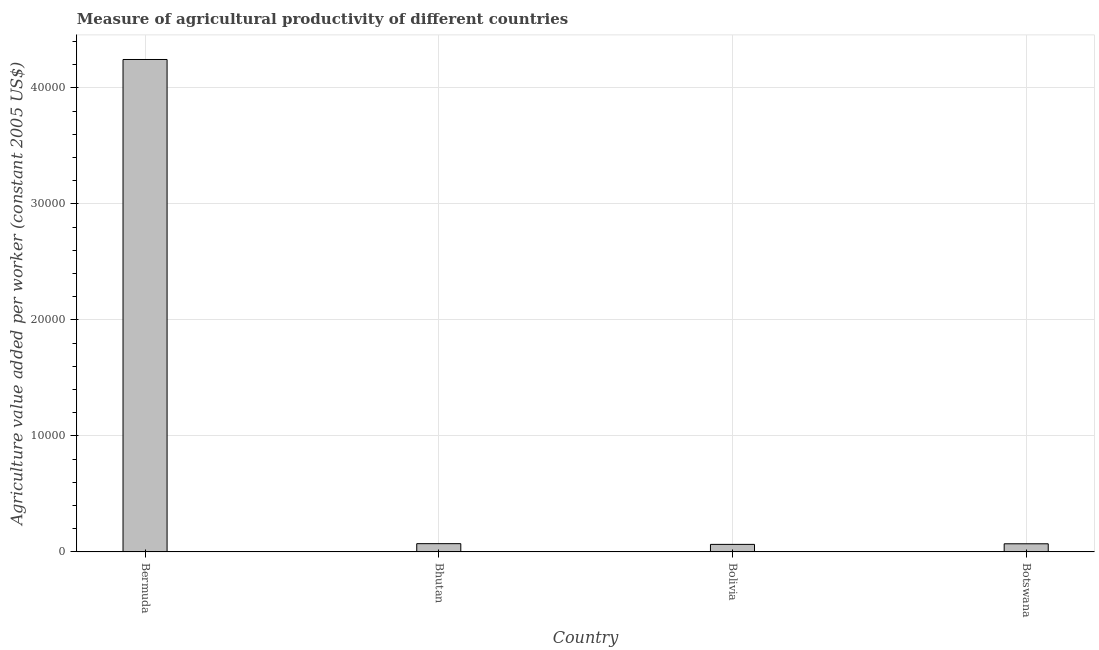Does the graph contain any zero values?
Your answer should be very brief. No. Does the graph contain grids?
Keep it short and to the point. Yes. What is the title of the graph?
Offer a terse response. Measure of agricultural productivity of different countries. What is the label or title of the Y-axis?
Offer a very short reply. Agriculture value added per worker (constant 2005 US$). What is the agriculture value added per worker in Bermuda?
Keep it short and to the point. 4.24e+04. Across all countries, what is the maximum agriculture value added per worker?
Provide a succinct answer. 4.24e+04. Across all countries, what is the minimum agriculture value added per worker?
Offer a very short reply. 649.37. In which country was the agriculture value added per worker maximum?
Give a very brief answer. Bermuda. In which country was the agriculture value added per worker minimum?
Provide a succinct answer. Bolivia. What is the sum of the agriculture value added per worker?
Your answer should be very brief. 4.45e+04. What is the difference between the agriculture value added per worker in Bhutan and Bolivia?
Provide a short and direct response. 60.99. What is the average agriculture value added per worker per country?
Offer a terse response. 1.11e+04. What is the median agriculture value added per worker?
Ensure brevity in your answer.  705.15. What is the ratio of the agriculture value added per worker in Bhutan to that in Bolivia?
Give a very brief answer. 1.09. Is the agriculture value added per worker in Bolivia less than that in Botswana?
Your answer should be compact. Yes. Is the difference between the agriculture value added per worker in Bermuda and Botswana greater than the difference between any two countries?
Keep it short and to the point. No. What is the difference between the highest and the second highest agriculture value added per worker?
Your answer should be very brief. 4.17e+04. Is the sum of the agriculture value added per worker in Bermuda and Bhutan greater than the maximum agriculture value added per worker across all countries?
Offer a terse response. Yes. What is the difference between the highest and the lowest agriculture value added per worker?
Offer a very short reply. 4.18e+04. In how many countries, is the agriculture value added per worker greater than the average agriculture value added per worker taken over all countries?
Your answer should be very brief. 1. How many bars are there?
Your answer should be compact. 4. Are all the bars in the graph horizontal?
Give a very brief answer. No. How many countries are there in the graph?
Your response must be concise. 4. What is the Agriculture value added per worker (constant 2005 US$) in Bermuda?
Your answer should be very brief. 4.24e+04. What is the Agriculture value added per worker (constant 2005 US$) of Bhutan?
Offer a very short reply. 710.36. What is the Agriculture value added per worker (constant 2005 US$) in Bolivia?
Your answer should be compact. 649.37. What is the Agriculture value added per worker (constant 2005 US$) in Botswana?
Offer a terse response. 699.93. What is the difference between the Agriculture value added per worker (constant 2005 US$) in Bermuda and Bhutan?
Give a very brief answer. 4.17e+04. What is the difference between the Agriculture value added per worker (constant 2005 US$) in Bermuda and Bolivia?
Provide a short and direct response. 4.18e+04. What is the difference between the Agriculture value added per worker (constant 2005 US$) in Bermuda and Botswana?
Ensure brevity in your answer.  4.17e+04. What is the difference between the Agriculture value added per worker (constant 2005 US$) in Bhutan and Bolivia?
Keep it short and to the point. 60.99. What is the difference between the Agriculture value added per worker (constant 2005 US$) in Bhutan and Botswana?
Provide a succinct answer. 10.43. What is the difference between the Agriculture value added per worker (constant 2005 US$) in Bolivia and Botswana?
Offer a very short reply. -50.56. What is the ratio of the Agriculture value added per worker (constant 2005 US$) in Bermuda to that in Bhutan?
Your answer should be compact. 59.75. What is the ratio of the Agriculture value added per worker (constant 2005 US$) in Bermuda to that in Bolivia?
Make the answer very short. 65.36. What is the ratio of the Agriculture value added per worker (constant 2005 US$) in Bermuda to that in Botswana?
Give a very brief answer. 60.64. What is the ratio of the Agriculture value added per worker (constant 2005 US$) in Bhutan to that in Bolivia?
Ensure brevity in your answer.  1.09. What is the ratio of the Agriculture value added per worker (constant 2005 US$) in Bhutan to that in Botswana?
Provide a short and direct response. 1.01. What is the ratio of the Agriculture value added per worker (constant 2005 US$) in Bolivia to that in Botswana?
Your response must be concise. 0.93. 